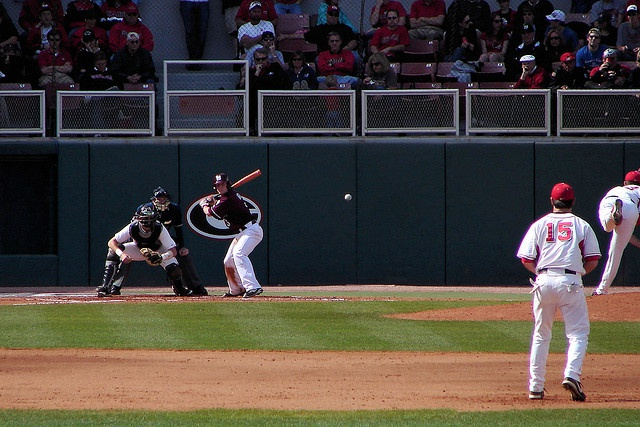Describe the objects in this image and their specific colors. I can see people in black, maroon, navy, and gray tones, people in black, darkgray, and white tones, people in black, lavender, and darkgray tones, people in black, gray, darkgray, and white tones, and people in black, white, gray, and darkgray tones in this image. 